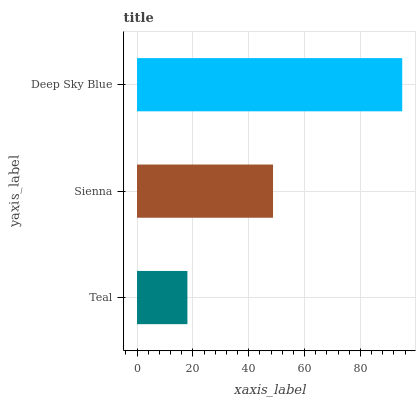Is Teal the minimum?
Answer yes or no. Yes. Is Deep Sky Blue the maximum?
Answer yes or no. Yes. Is Sienna the minimum?
Answer yes or no. No. Is Sienna the maximum?
Answer yes or no. No. Is Sienna greater than Teal?
Answer yes or no. Yes. Is Teal less than Sienna?
Answer yes or no. Yes. Is Teal greater than Sienna?
Answer yes or no. No. Is Sienna less than Teal?
Answer yes or no. No. Is Sienna the high median?
Answer yes or no. Yes. Is Sienna the low median?
Answer yes or no. Yes. Is Deep Sky Blue the high median?
Answer yes or no. No. Is Deep Sky Blue the low median?
Answer yes or no. No. 